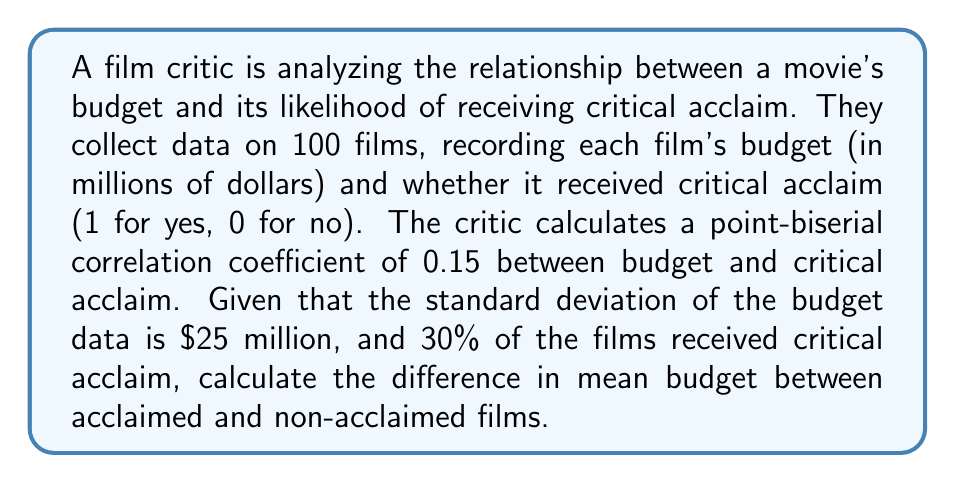Help me with this question. To solve this problem, we'll use the point-biserial correlation formula and work backwards to find the difference in mean budgets. Let's break it down step-by-step:

1) The point-biserial correlation coefficient formula is:

   $$r_{pb} = \frac{M_1 - M_0}{s_n} \sqrt{\frac{p(1-p)}{n}}$$

   Where:
   $r_{pb}$ = point-biserial correlation coefficient
   $M_1$ = mean of the continuous variable for group 1 (acclaimed films)
   $M_0$ = mean of the continuous variable for group 0 (non-acclaimed films)
   $s_n$ = standard deviation of the continuous variable (budget)
   $p$ = proportion of cases in group 1
   $n$ = total sample size

2) We're given:
   $r_{pb} = 0.15$
   $s_n = 25$ (million dollars)
   $p = 0.30$ (30% of films received acclaim)
   $n = 100$

3) Let's substitute these values into the formula:

   $$0.15 = \frac{M_1 - M_0}{25} \sqrt{\frac{0.30(1-0.30)}{100}}$$

4) Simplify the right side:

   $$0.15 = \frac{M_1 - M_0}{25} \sqrt{\frac{0.21}{100}} = \frac{M_1 - M_0}{25} \cdot 0.0458$$

5) Multiply both sides by 25:

   $$3.75 = (M_1 - M_0) \cdot 0.0458$$

6) Divide both sides by 0.0458:

   $$81.88 = M_1 - M_0$$

Therefore, the difference in mean budget between acclaimed and non-acclaimed films is approximately $81.88 million.
Answer: $81.88 million 